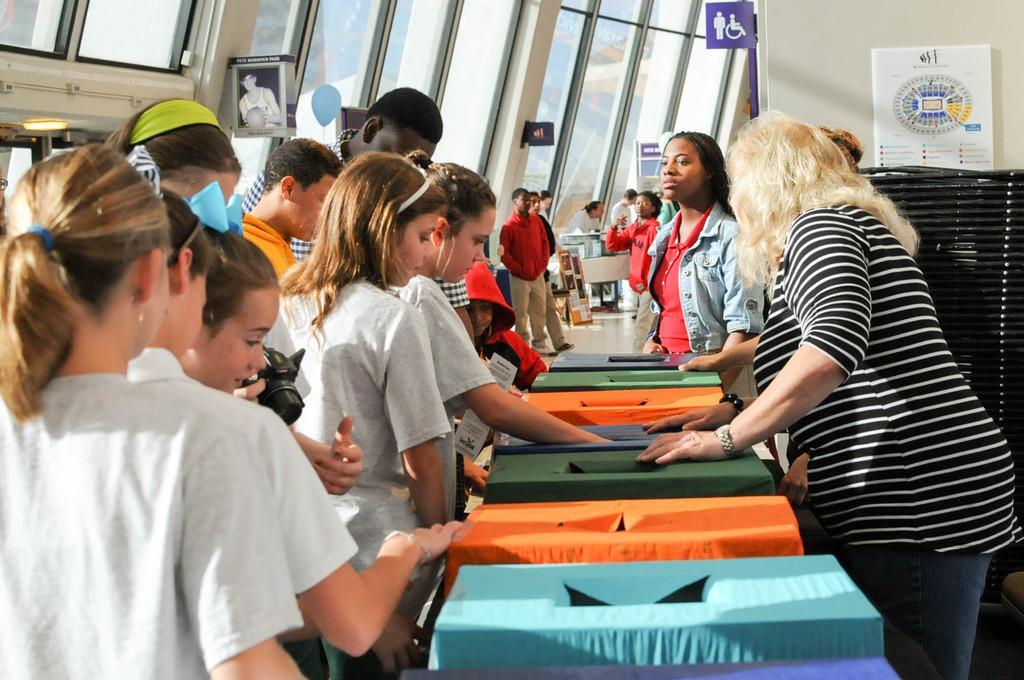How many people are present in the image? There are persons in the image, but the exact number cannot be determined from the provided facts. What objects can be seen in the image besides the persons? There are boxes, a table, and various items in the background, including a wall, boards, a light, and glasses. What type of surface is visible in the image? The image shows a floor. What type of cheese is being offered for selection in the image? There is no cheese present in the image, and therefore no such selection can be observed. 